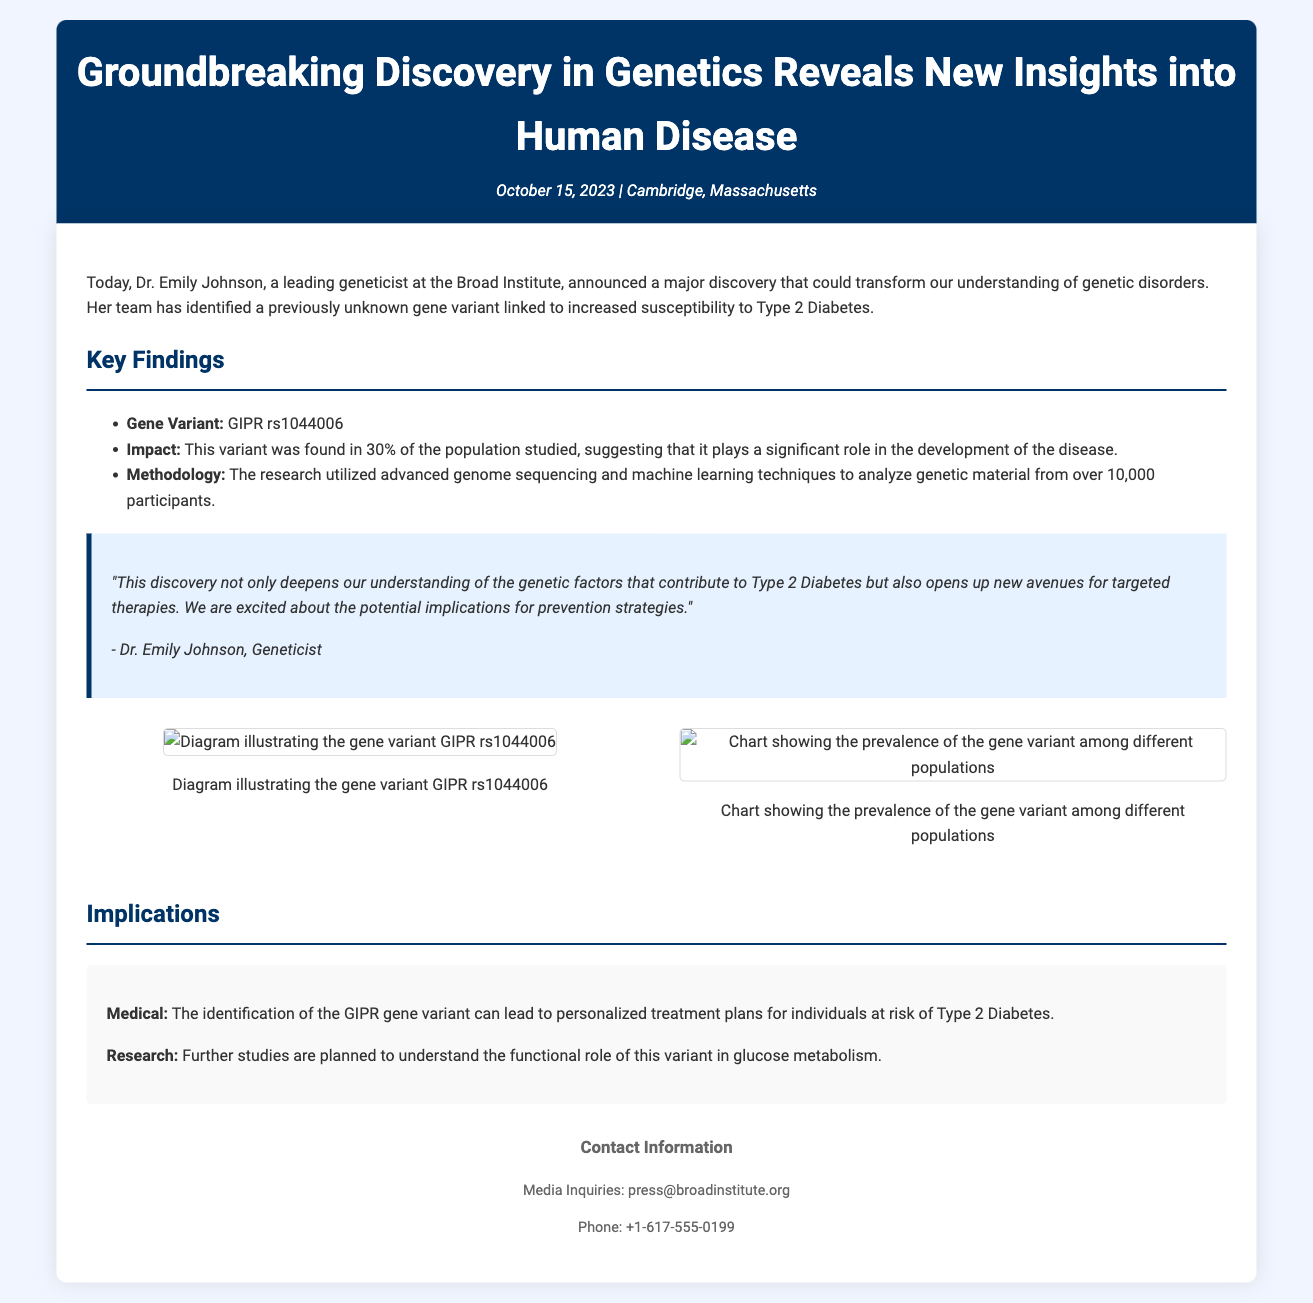What is the name of the geneticist making the announcement? The document specifically states that Dr. Emily Johnson is the geneticist who announced the discovery.
Answer: Dr. Emily Johnson What is the gene variant identified in the study? The document highlights the gene variant as GIPR rs1044006.
Answer: GIPR rs1044006 What percentage of the population studied carried the gene variant? According to the document, the variant was found in 30% of the population studied.
Answer: 30% What methodologies were used in the research? The document notes that advanced genome sequencing and machine learning techniques were employed for the study.
Answer: Advanced genome sequencing and machine learning What potential implications does the discovery have for treatment? The identification of the GIPR gene variant may lead to personalized treatment plans for individuals at risk of Type 2 Diabetes, as stated in the implications section.
Answer: Personalized treatment plans Which institution is Dr. Emily Johnson affiliated with? The document specifies that she is a leading geneticist at the Broad Institute.
Answer: Broad Institute What is the date of the press release? The document states that the press release was made on October 15, 2023.
Answer: October 15, 2023 What can further studies aim to understand about the gene variant? The document mentions that further studies are planned to understand the functional role of this variant in glucose metabolism.
Answer: Functional role in glucose metabolism 